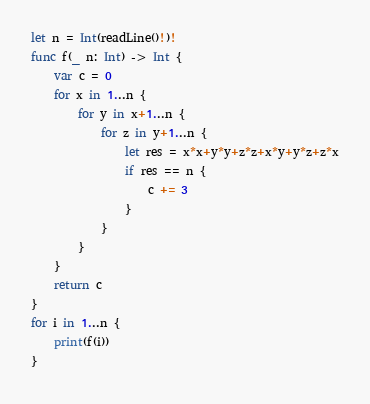<code> <loc_0><loc_0><loc_500><loc_500><_Swift_>let n = Int(readLine()!)!
func f(_ n: Int) -> Int {
    var c = 0
    for x in 1...n {
        for y in x+1...n {
            for z in y+1...n {
                let res = x*x+y*y+z*z+x*y+y*z+z*x
                if res == n {
                    c += 3
                }
            }
        }
    }
    return c
}
for i in 1...n {
    print(f(i))
}
</code> 